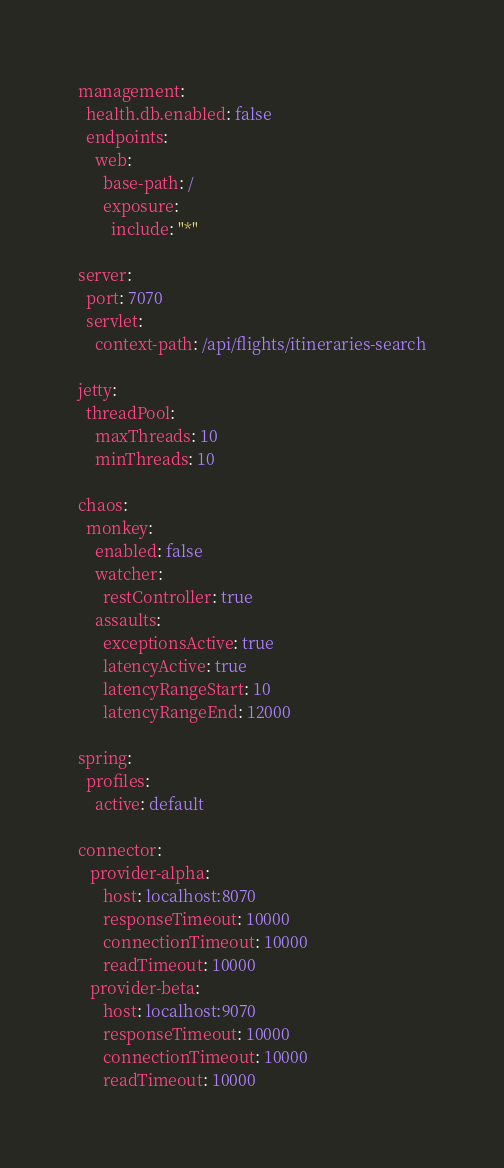Convert code to text. <code><loc_0><loc_0><loc_500><loc_500><_YAML_>management:
  health.db.enabled: false
  endpoints:
    web:
      base-path: /
      exposure:
        include: "*"

server:
  port: 7070
  servlet:
    context-path: /api/flights/itineraries-search

jetty:
  threadPool:
    maxThreads: 10
    minThreads: 10

chaos:
  monkey:
    enabled: false
    watcher:
      restController: true
    assaults:
      exceptionsActive: true
      latencyActive: true
      latencyRangeStart: 10
      latencyRangeEnd: 12000

spring:
  profiles:
    active: default

connector:
   provider-alpha:
      host: localhost:8070
      responseTimeout: 10000
      connectionTimeout: 10000
      readTimeout: 10000
   provider-beta:
      host: localhost:9070
      responseTimeout: 10000
      connectionTimeout: 10000
      readTimeout: 10000
</code> 